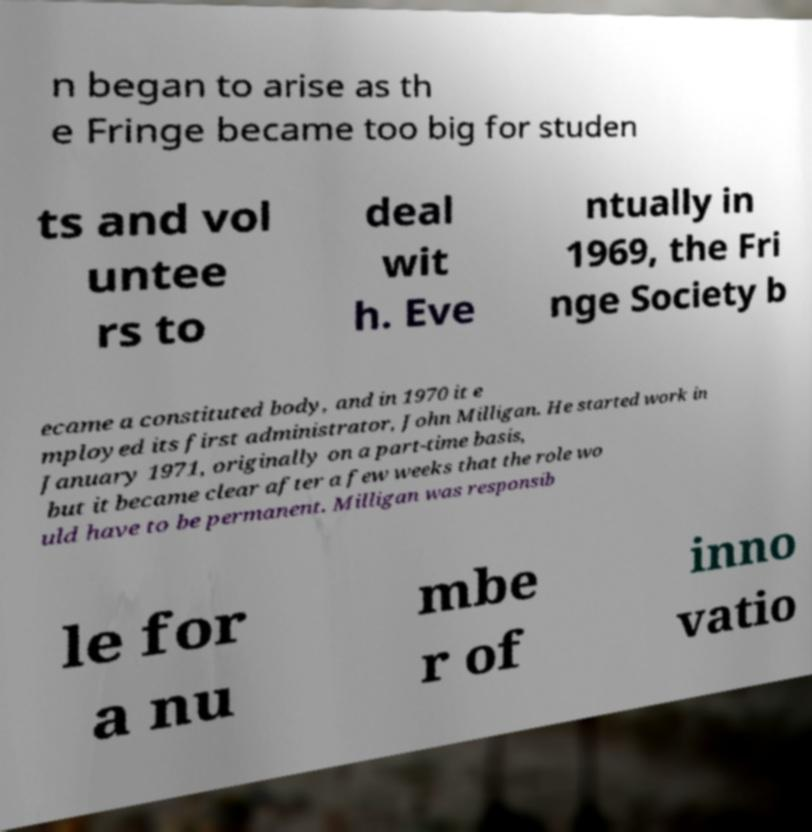Can you accurately transcribe the text from the provided image for me? n began to arise as th e Fringe became too big for studen ts and vol untee rs to deal wit h. Eve ntually in 1969, the Fri nge Society b ecame a constituted body, and in 1970 it e mployed its first administrator, John Milligan. He started work in January 1971, originally on a part-time basis, but it became clear after a few weeks that the role wo uld have to be permanent. Milligan was responsib le for a nu mbe r of inno vatio 